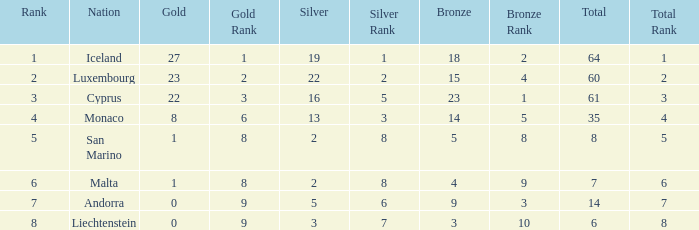How many golds for the nation with 14 total? 0.0. 